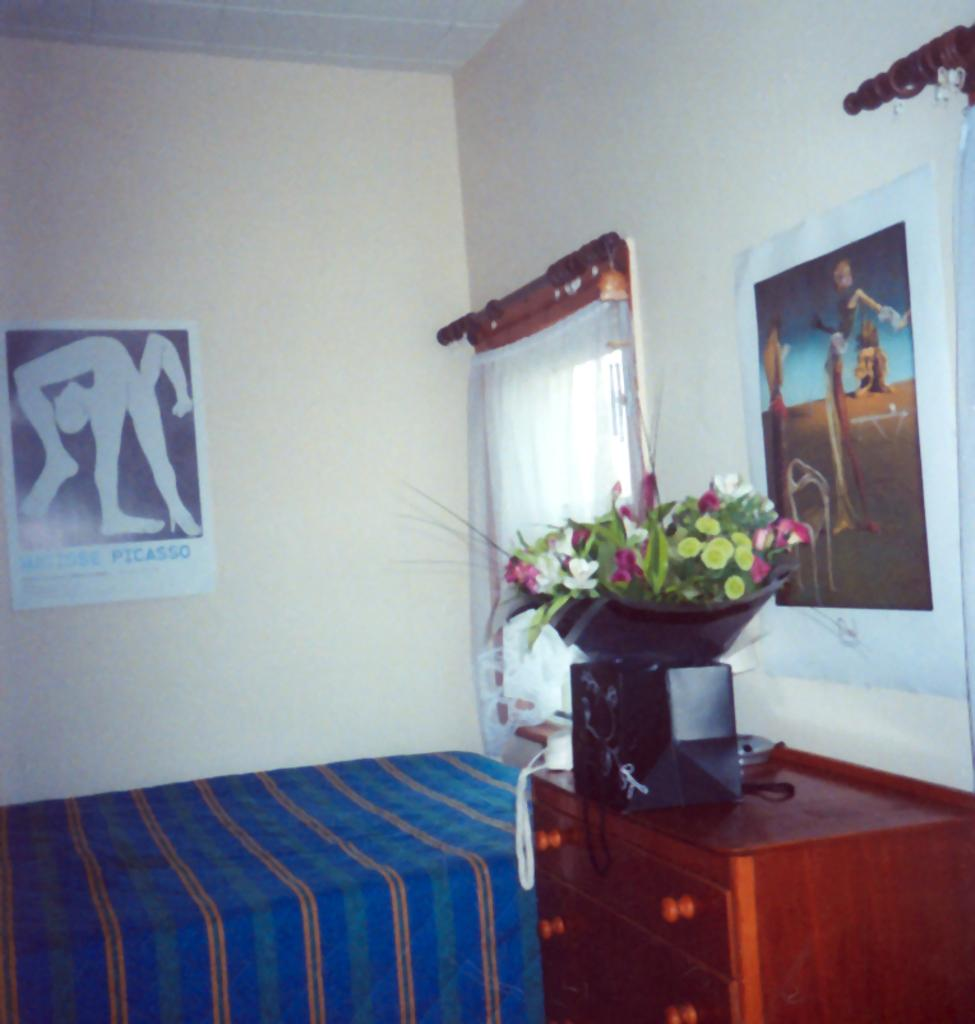What type of furniture is present in the image? There is a bed in the image. What decorative item can be seen in the room? There is a flower vase in the image. What storage unit is visible in the image? There is a cupboard in the image. What type of window treatment is present in the image? There is a curtain in the image. What architectural feature is visible in the image? There is a window in the image. What type of wall decorations are present in the image? There are posters in the image. What type of surface is present in the image? There is a wall in the image. How many trucks are parked outside the window in the image? There are no trucks visible in the image; it only shows a bed, flower vase, cupboard, curtain, window, posters, and wall. Is there a guide available to help navigate the room in the image? There is no guide present in the image, as it is a still photograph of a room. 